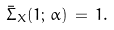<formula> <loc_0><loc_0><loc_500><loc_500>\bar { \Sigma } _ { X } ( 1 ; \, \alpha ) \, = \, 1 .</formula> 